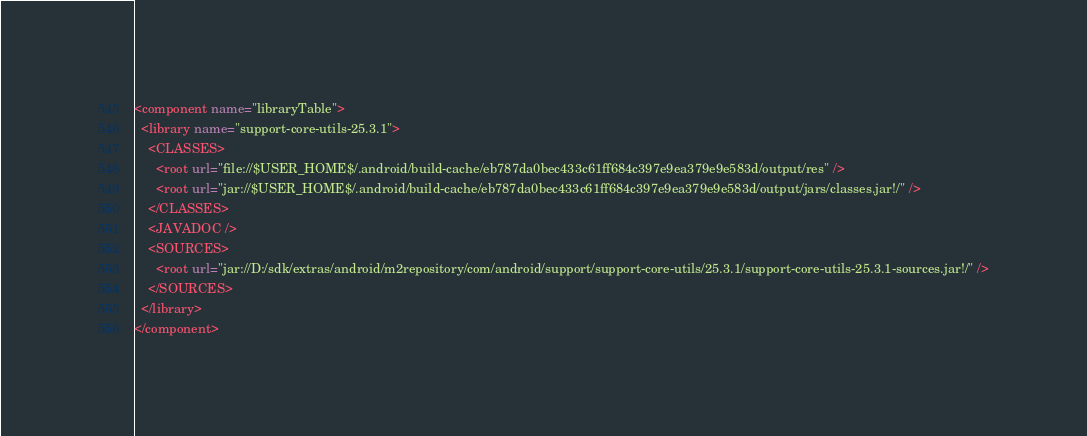<code> <loc_0><loc_0><loc_500><loc_500><_XML_><component name="libraryTable">
  <library name="support-core-utils-25.3.1">
    <CLASSES>
      <root url="file://$USER_HOME$/.android/build-cache/eb787da0bec433c61ff684c397e9ea379e9e583d/output/res" />
      <root url="jar://$USER_HOME$/.android/build-cache/eb787da0bec433c61ff684c397e9ea379e9e583d/output/jars/classes.jar!/" />
    </CLASSES>
    <JAVADOC />
    <SOURCES>
      <root url="jar://D:/sdk/extras/android/m2repository/com/android/support/support-core-utils/25.3.1/support-core-utils-25.3.1-sources.jar!/" />
    </SOURCES>
  </library>
</component></code> 